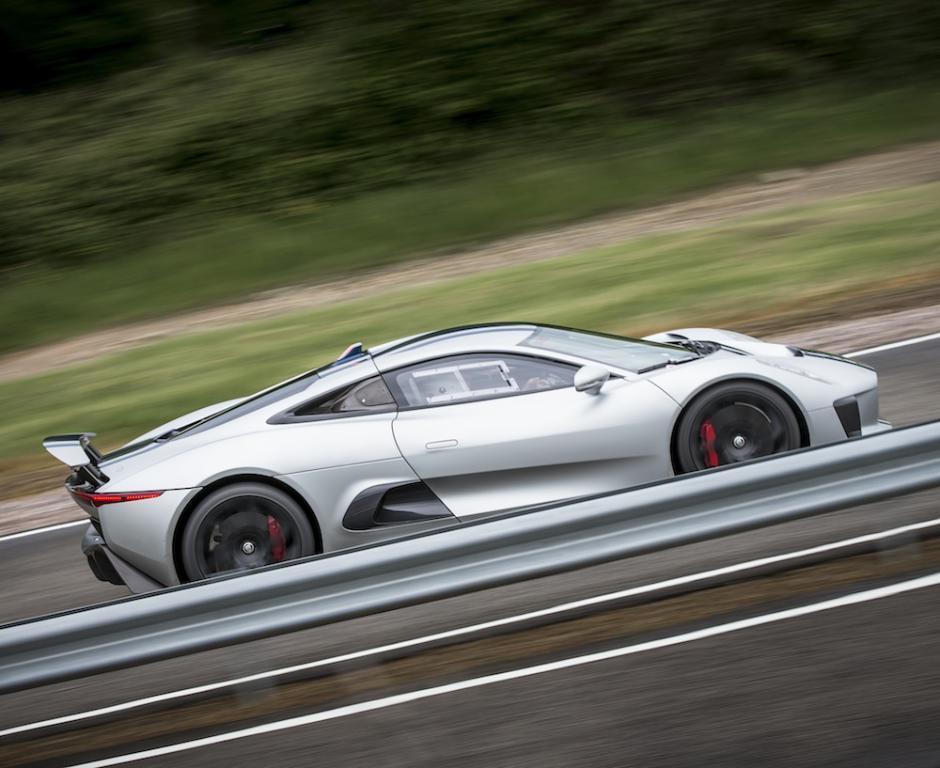In one or two sentences, can you explain what this image depicts? This picture is clicked outside the city. In the foreground we can see the ground. In the center there is a car seems to be running on the road. In the background we can see the green grass and the trees. 